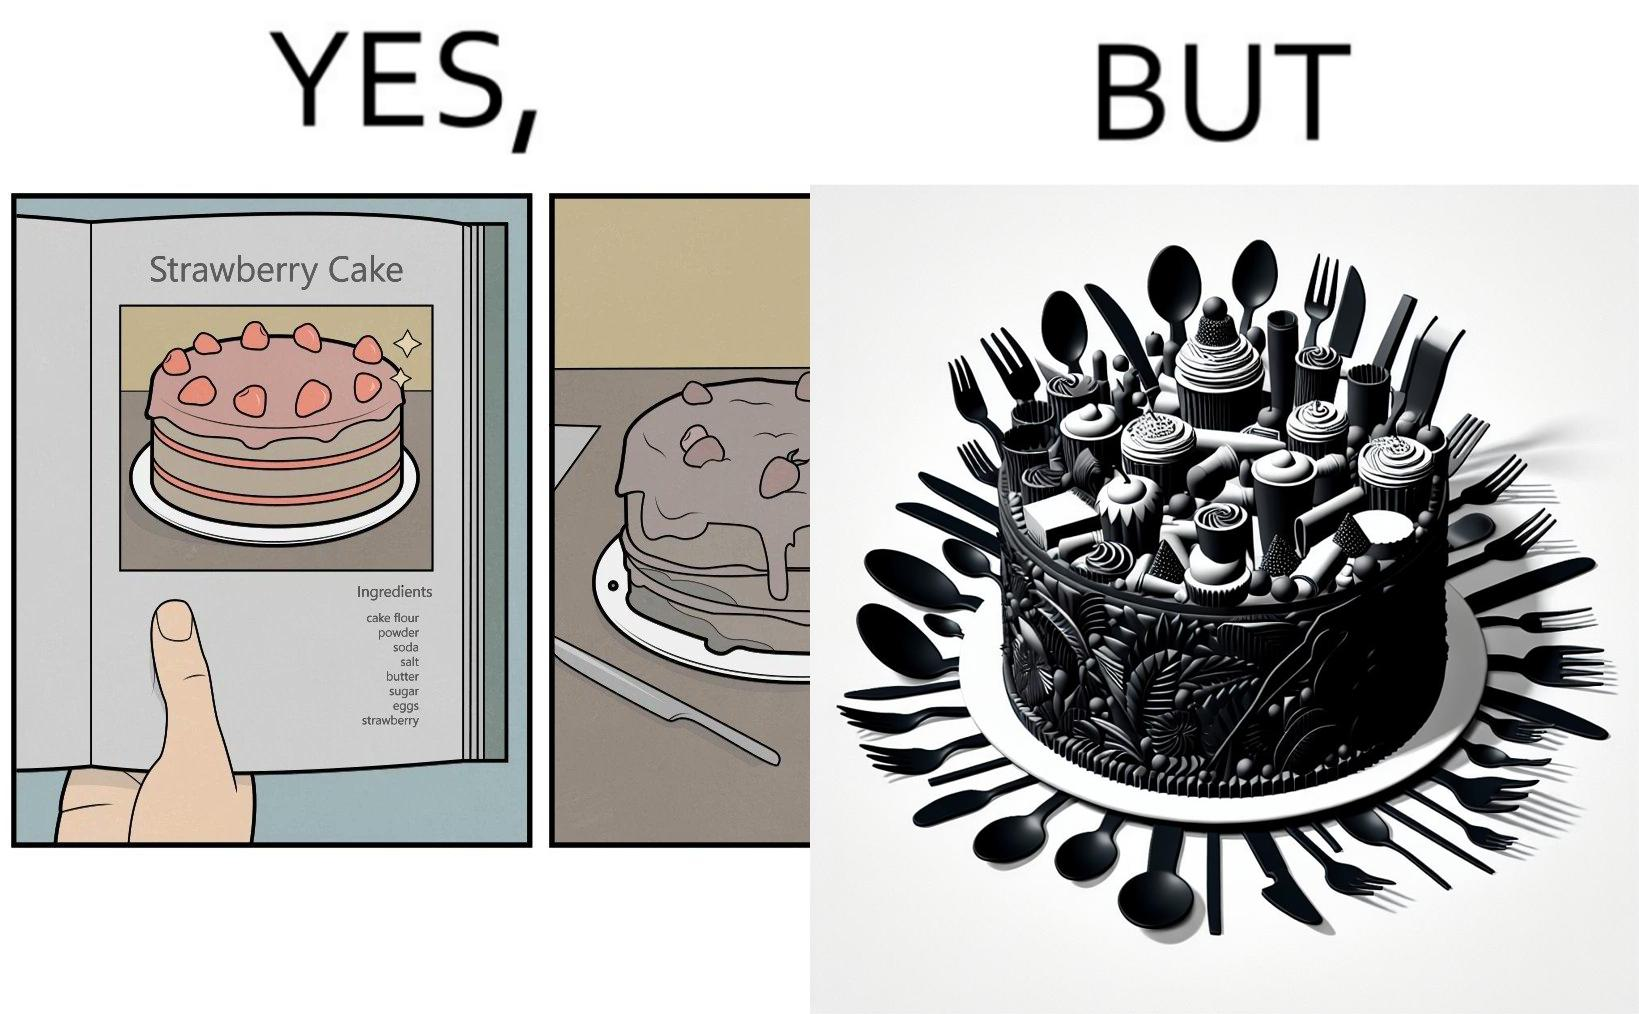Describe the contrast between the left and right parts of this image. In the left part of the image: a page of a book showing the image of a strawberry cake, along with its ingredients. In the right part of the image: a cake on a plate, along with a bunch of used utensils to be washed. 